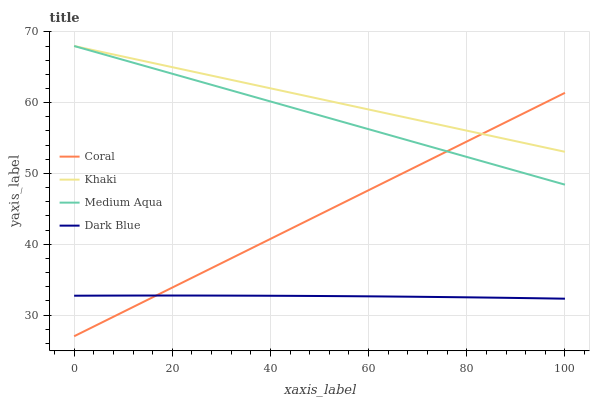Does Coral have the minimum area under the curve?
Answer yes or no. No. Does Coral have the maximum area under the curve?
Answer yes or no. No. Is Coral the smoothest?
Answer yes or no. No. Is Coral the roughest?
Answer yes or no. No. Does Khaki have the lowest value?
Answer yes or no. No. Does Coral have the highest value?
Answer yes or no. No. Is Dark Blue less than Medium Aqua?
Answer yes or no. Yes. Is Khaki greater than Dark Blue?
Answer yes or no. Yes. Does Dark Blue intersect Medium Aqua?
Answer yes or no. No. 